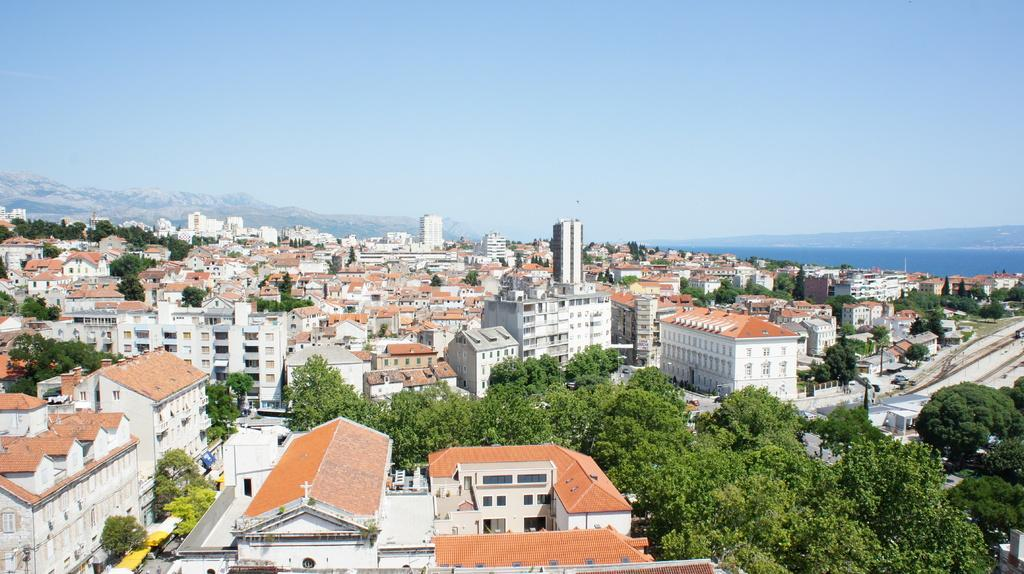What type of structures can be seen in the image? There are many buildings in the image. What other natural elements are present in the image? There are trees in the image. What can be seen to the right of the image? There are poles visible to the right of the image. What mode of transportation is present in the image? There is a train on the track in the image. What can be seen in the distance in the image? There are mountains visible in the background of the image, and the sky is also visible. Can you tell me how many jars of jelly are on the train in the image? There is no mention of jelly or jars in the image; it features a train on a track with buildings, trees, poles, mountains, and the sky in the background. Is there a girl with a partner walking through the mountains in the image? There is no girl or partner present in the image; it only shows a train, buildings, trees, poles, mountains, and the sky. 